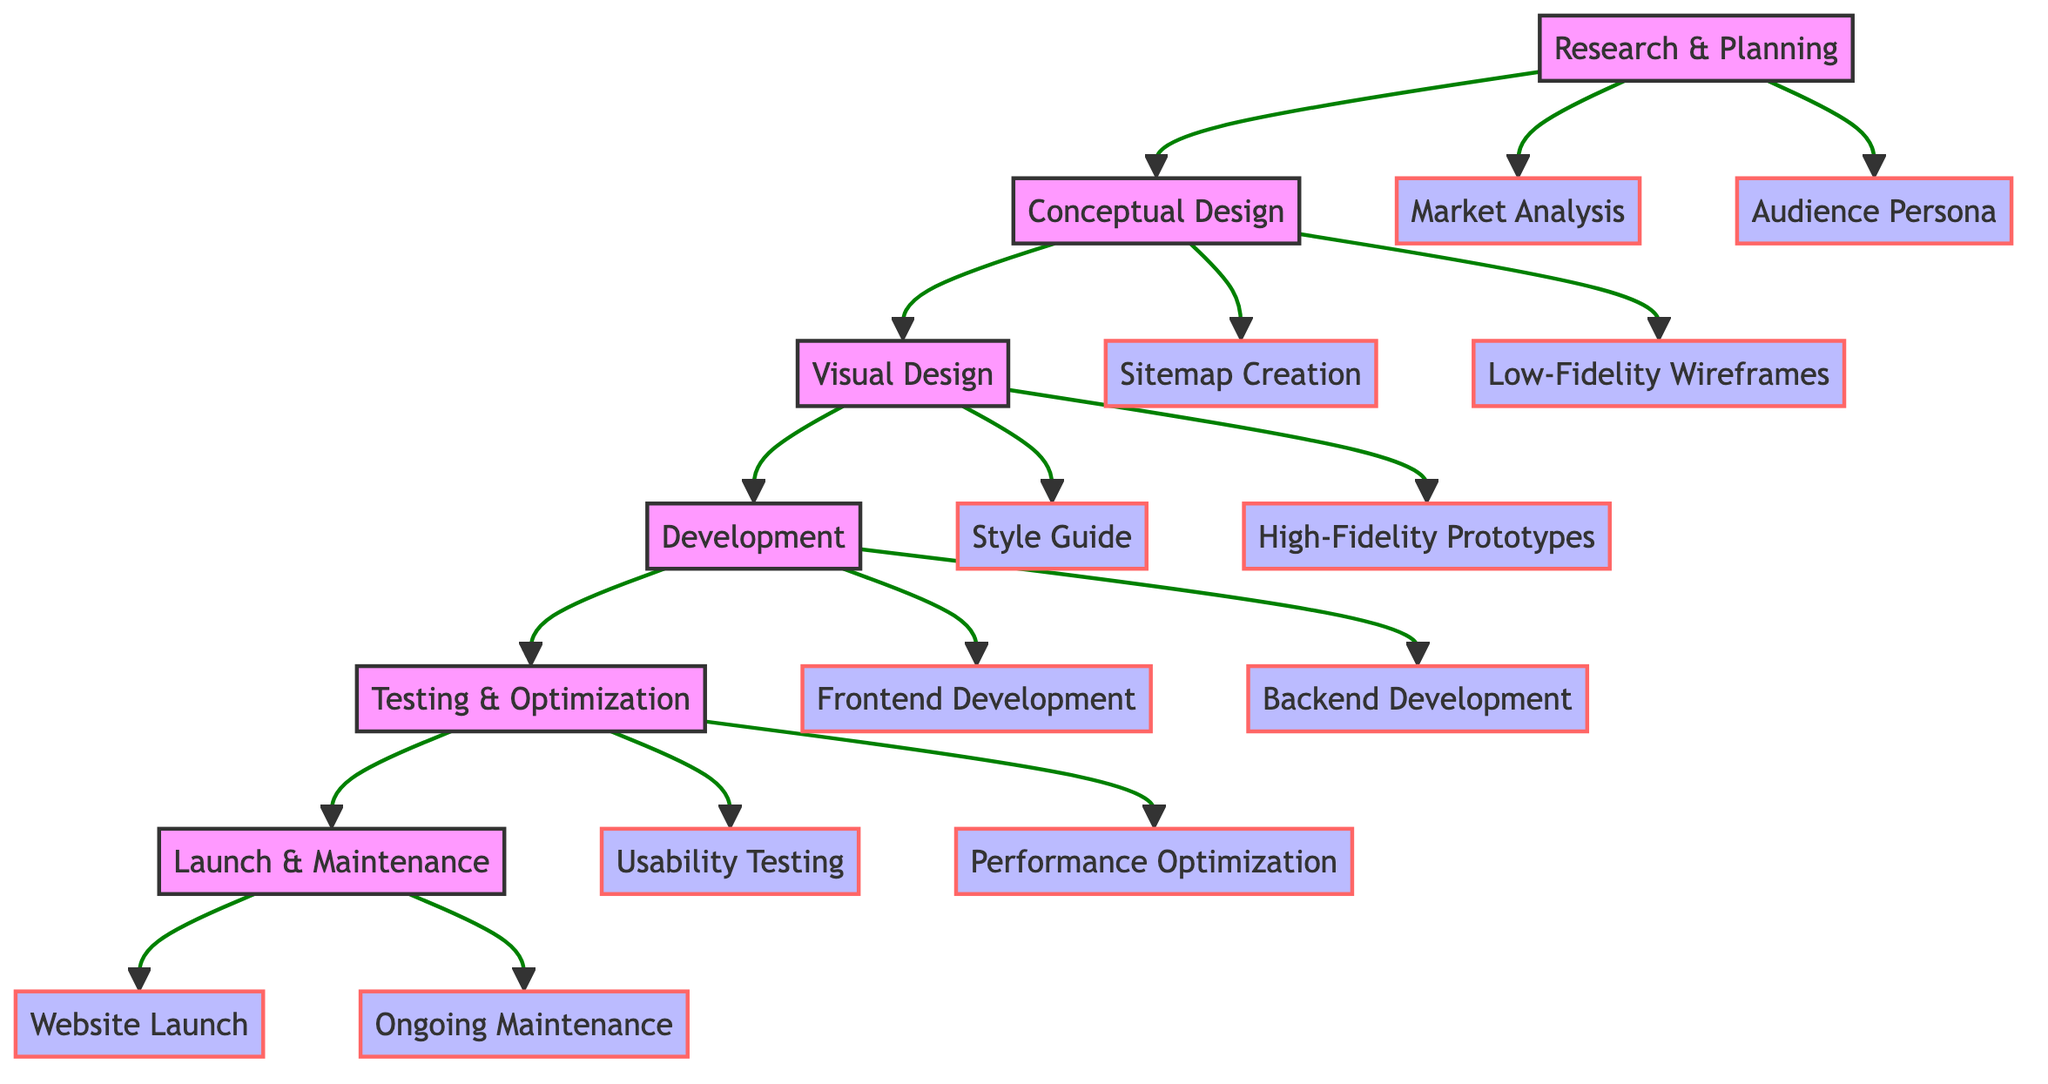What is the first step in the workflow? The diagram indicates that "Research & Planning" is the first step, as it is the starting point before any other actions are taken in the workflow.
Answer: Research & Planning How many main nodes are there in the workflow? The diagram lists five main nodes: Research & Planning, Conceptual Design, Visual Design, Development, and Testing & Optimization. Therefore, there are a total of five main steps.
Answer: 5 What follows the Visual Design step? The flow chart shows that "Development" follows "Visual Design," which means that after establishing the website's look and feel, the next step is to bring those designs to life.
Answer: Development Which main node is connected to both Market Analysis and Audience Persona? "Research & Planning" is connected to both Market Analysis and Audience Persona as sub-elements, indicating that these analyses are part of the initial research phase.
Answer: Research & Planning What are the two sub-elements under the Testing & Optimization node? Under the Testing & Optimization main node, the diagram shows two sub-elements: "Usability Testing" and "Performance Optimization." These reflect key aspects of ensuring the site meets user needs and performs well.
Answer: Usability Testing, Performance Optimization Which step comes before the Launch & Maintenance step? The step that comes directly before "Launch & Maintenance" is "Testing & Optimization," indicating that testing and refining the site occurs before launching it to the public.
Answer: Testing & Optimization What is the purpose of the Development step? The purpose is clearly indicated as turning designs into a functional website, highlighting the transition from design plans to an actual working site.
Answer: Turn designs into a functional website How many sub-elements are associated with Visual Design? The sub-elements associated with "Visual Design" are "Style Guide" and "High-Fidelity Prototypes," making a total of two sub-elements for this step.
Answer: 2 Which node is the last in the sequence? The last node in the workflow is "Launch & Maintenance," which indicates that the workflow ends with the deployment and upkeep of the website.
Answer: Launch & Maintenance 